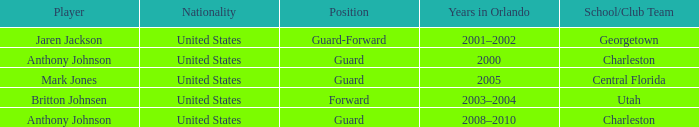Who was the Player that spent the Year 2005 in Orlando? Mark Jones. 